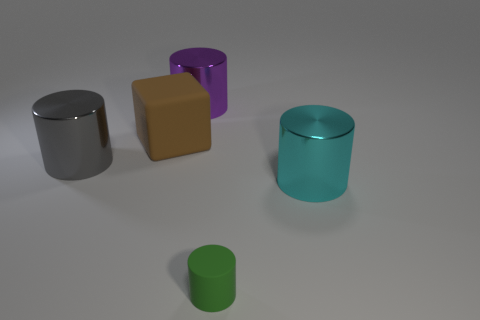Add 4 yellow cylinders. How many objects exist? 9 Subtract all cylinders. How many objects are left? 1 Add 3 big purple objects. How many big purple objects are left? 4 Add 2 large purple metal blocks. How many large purple metal blocks exist? 2 Subtract 0 yellow cylinders. How many objects are left? 5 Subtract all large things. Subtract all big purple cylinders. How many objects are left? 0 